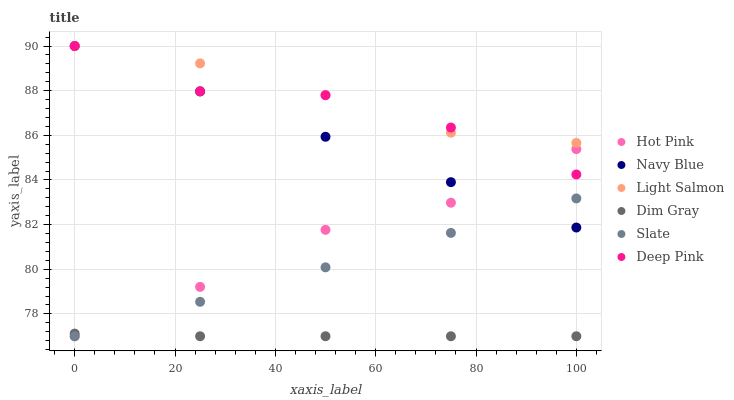Does Dim Gray have the minimum area under the curve?
Answer yes or no. Yes. Does Light Salmon have the maximum area under the curve?
Answer yes or no. Yes. Does Navy Blue have the minimum area under the curve?
Answer yes or no. No. Does Navy Blue have the maximum area under the curve?
Answer yes or no. No. Is Slate the smoothest?
Answer yes or no. Yes. Is Deep Pink the roughest?
Answer yes or no. Yes. Is Dim Gray the smoothest?
Answer yes or no. No. Is Dim Gray the roughest?
Answer yes or no. No. Does Dim Gray have the lowest value?
Answer yes or no. Yes. Does Navy Blue have the lowest value?
Answer yes or no. No. Does Deep Pink have the highest value?
Answer yes or no. Yes. Does Dim Gray have the highest value?
Answer yes or no. No. Is Dim Gray less than Deep Pink?
Answer yes or no. Yes. Is Light Salmon greater than Dim Gray?
Answer yes or no. Yes. Does Light Salmon intersect Navy Blue?
Answer yes or no. Yes. Is Light Salmon less than Navy Blue?
Answer yes or no. No. Is Light Salmon greater than Navy Blue?
Answer yes or no. No. Does Dim Gray intersect Deep Pink?
Answer yes or no. No. 